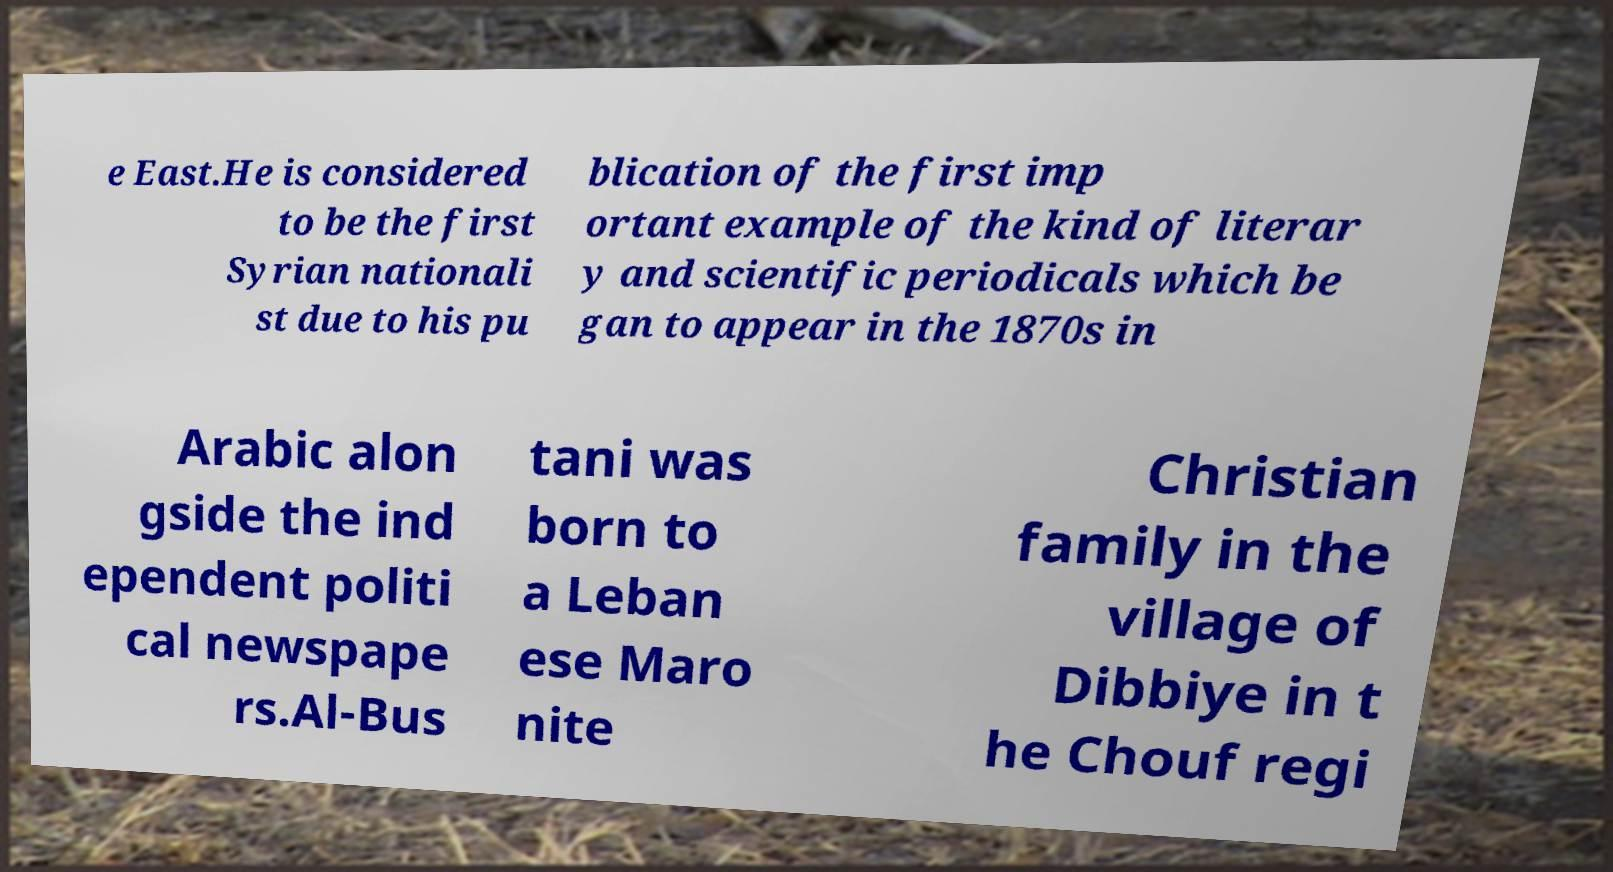There's text embedded in this image that I need extracted. Can you transcribe it verbatim? e East.He is considered to be the first Syrian nationali st due to his pu blication of the first imp ortant example of the kind of literar y and scientific periodicals which be gan to appear in the 1870s in Arabic alon gside the ind ependent politi cal newspape rs.Al-Bus tani was born to a Leban ese Maro nite Christian family in the village of Dibbiye in t he Chouf regi 